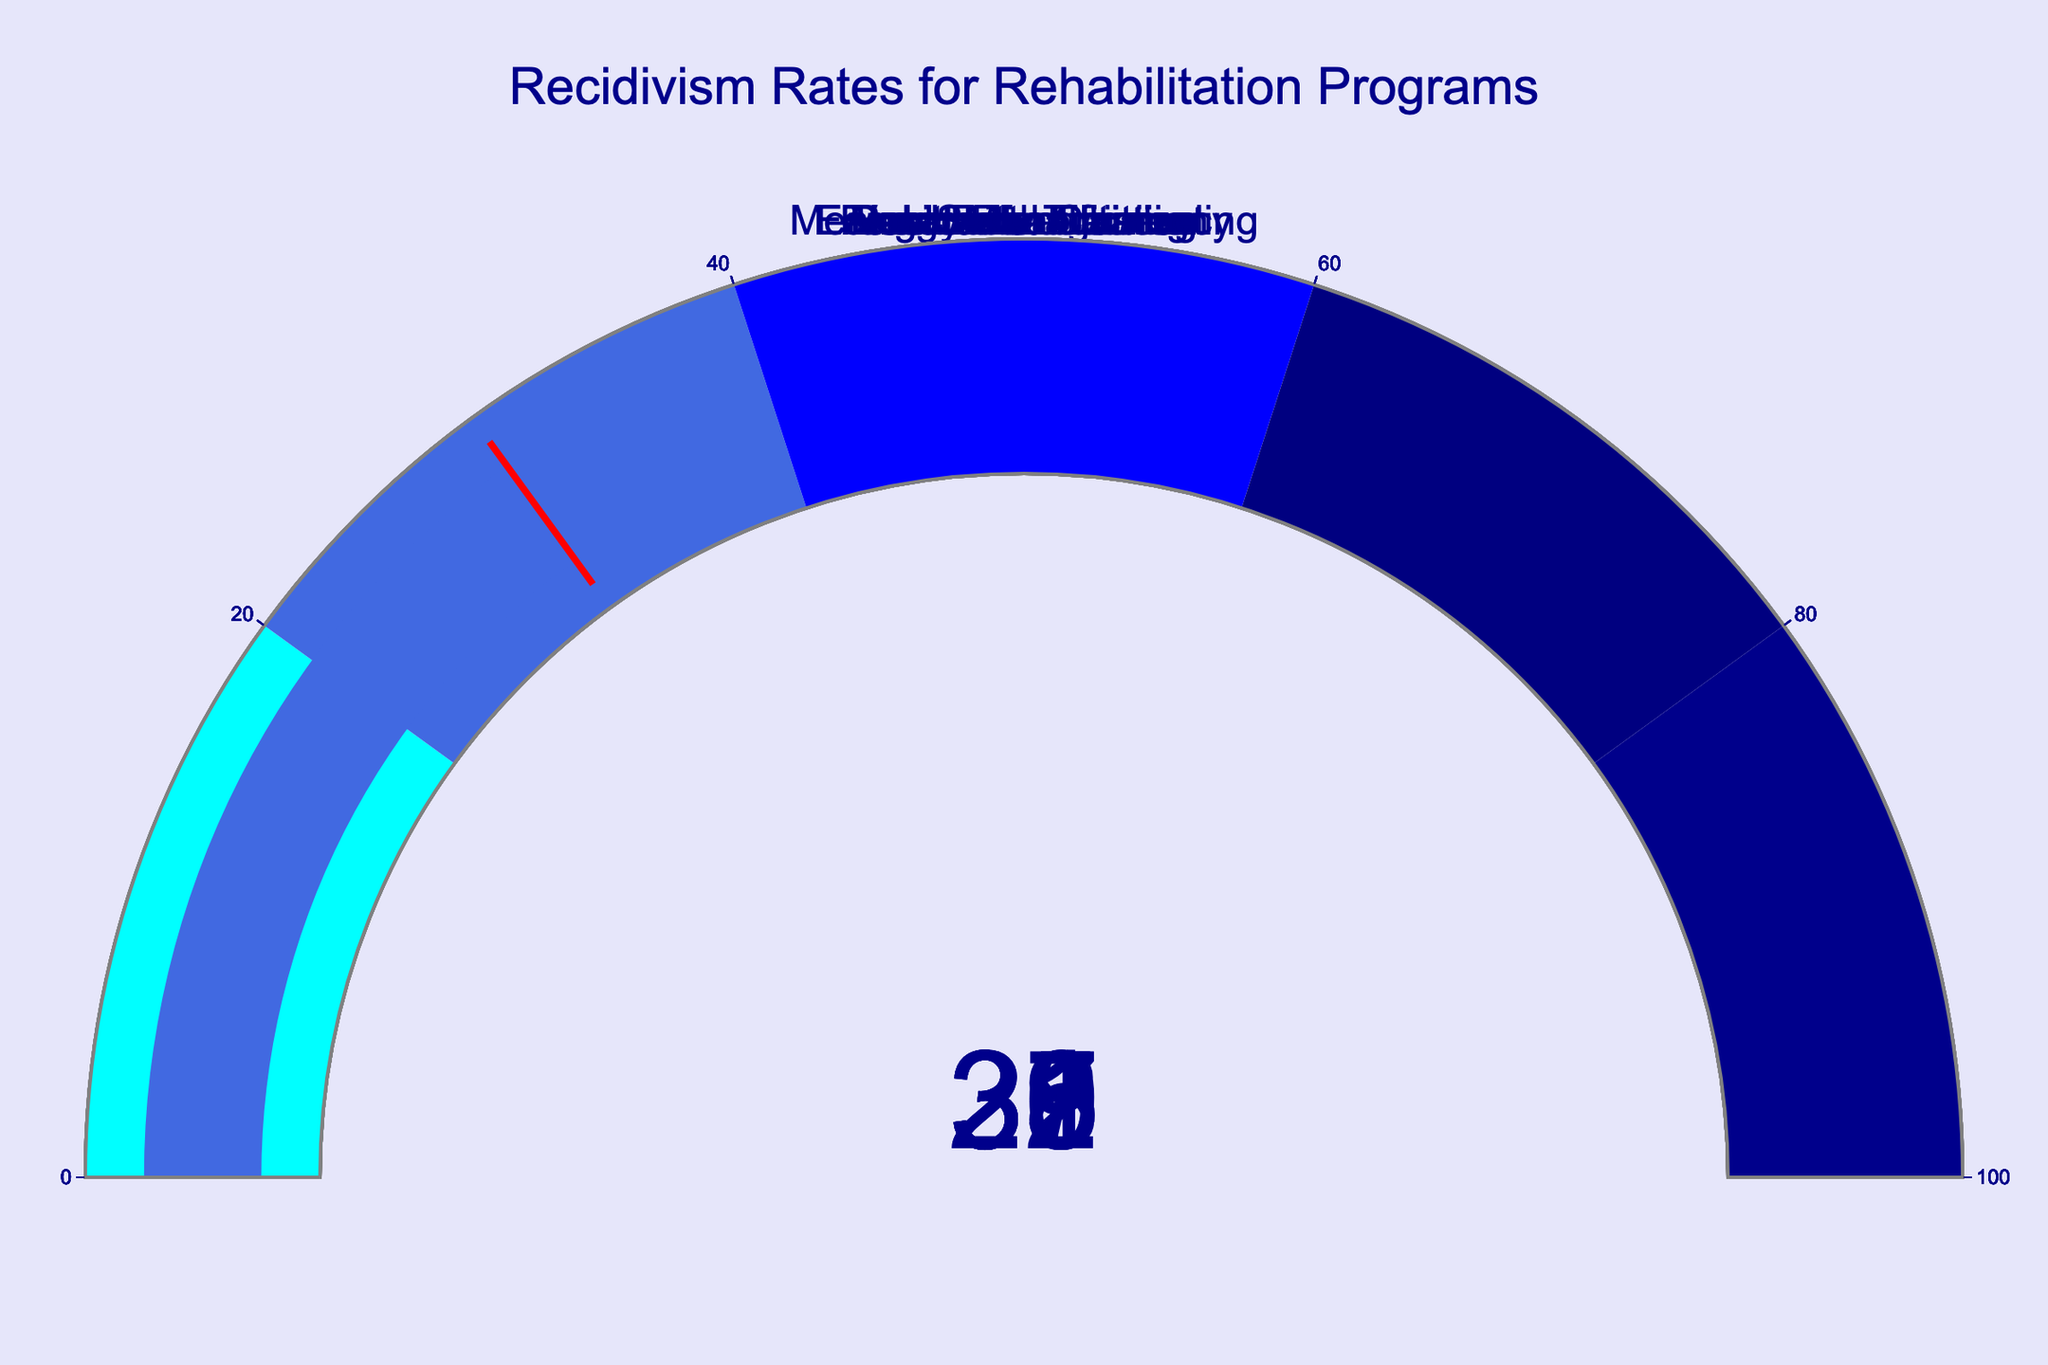What is the recidivism rate for the Drug Rehabilitation program? The gauge for "Drug Rehabilitation" shows the number 38, which represents the recidivism rate.
Answer: 38 How many programs have a recidivism rate lower than 30? The programs with rates lower than 30 are "Anger Management," "Education and Literacy," and "Family Reunification." That's 3 programs.
Answer: 3 Which program has the highest recidivism rate? By comparing all the gauges, "Drug Rehabilitation" has the highest rate at 38.
Answer: Drug Rehabilitation What is the difference in recidivism rates between the "Education and Literacy" program and the "Restorative Justice" program? "Education and Literacy" shows a rate of 25, while "Restorative Justice" shows 31. The difference is 31 - 25 = 6.
Answer: 6 Which programs have a recidivism rate higher than 30? The programs with rates higher than 30 are "Job Skills Training," "Drug Rehabilitation," "Mental Health Counseling," and "Restorative Justice."
Answer: Job Skills Training, Drug Rehabilitation, Mental Health Counseling, Restorative Justice What is the average recidivism rate across all programs? Summing all rates: 32 + 38 + 29 + 25 + 35 + 27 + 31 + 30 = 247. Dividing by the number of programs (8) gives 247 / 8 = 30.875.
Answer: 30.875 What is the median recidivism rate of the programs? Arrange the rates in ascending order: 25, 27, 29, 30, 31, 32, 35, 38. The middle two numbers are 30 and 31, and the median is (30 + 31) / 2 = 30.5.
Answer: 30.5 Which program has a recidivism rate closest to the average rate? The average rate is 30.875. The "Vocational Training" program has a rate of 30, which is the closest to 30.875.
Answer: Vocational Training 